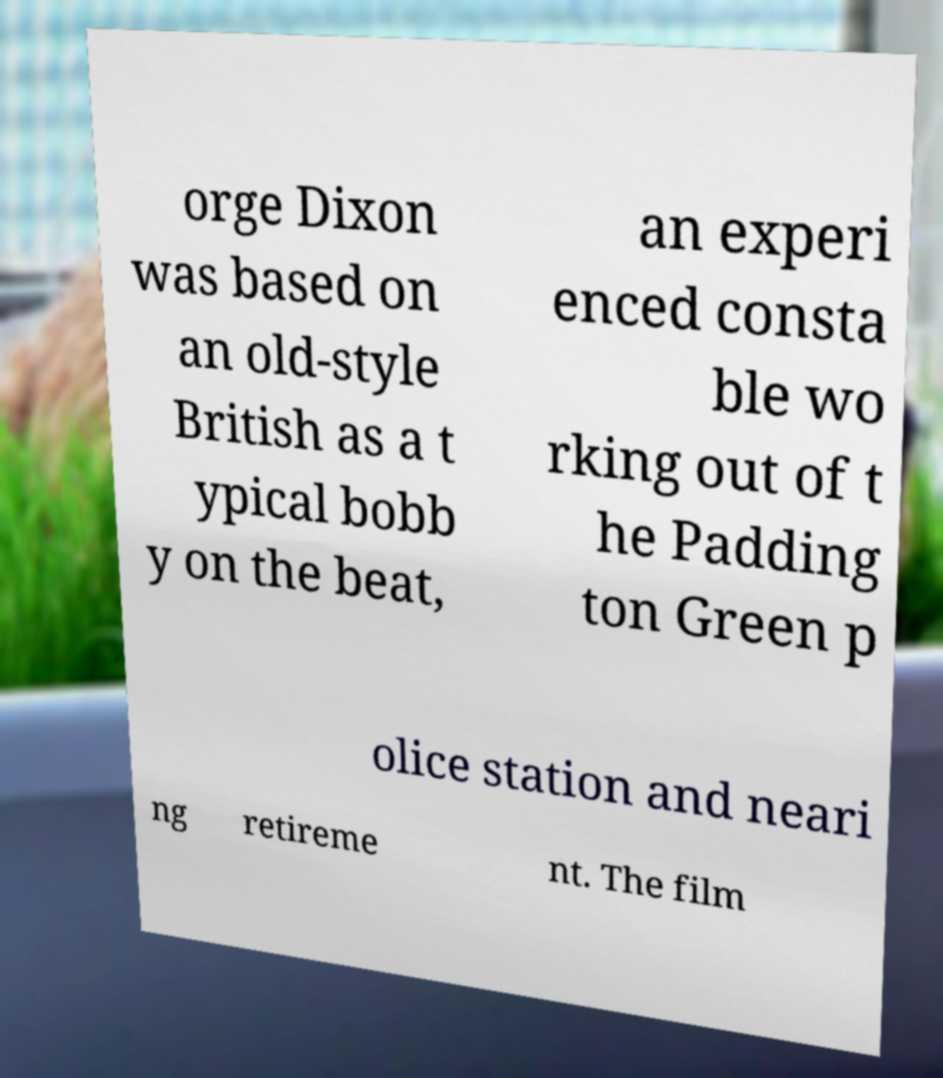I need the written content from this picture converted into text. Can you do that? orge Dixon was based on an old-style British as a t ypical bobb y on the beat, an experi enced consta ble wo rking out of t he Padding ton Green p olice station and neari ng retireme nt. The film 